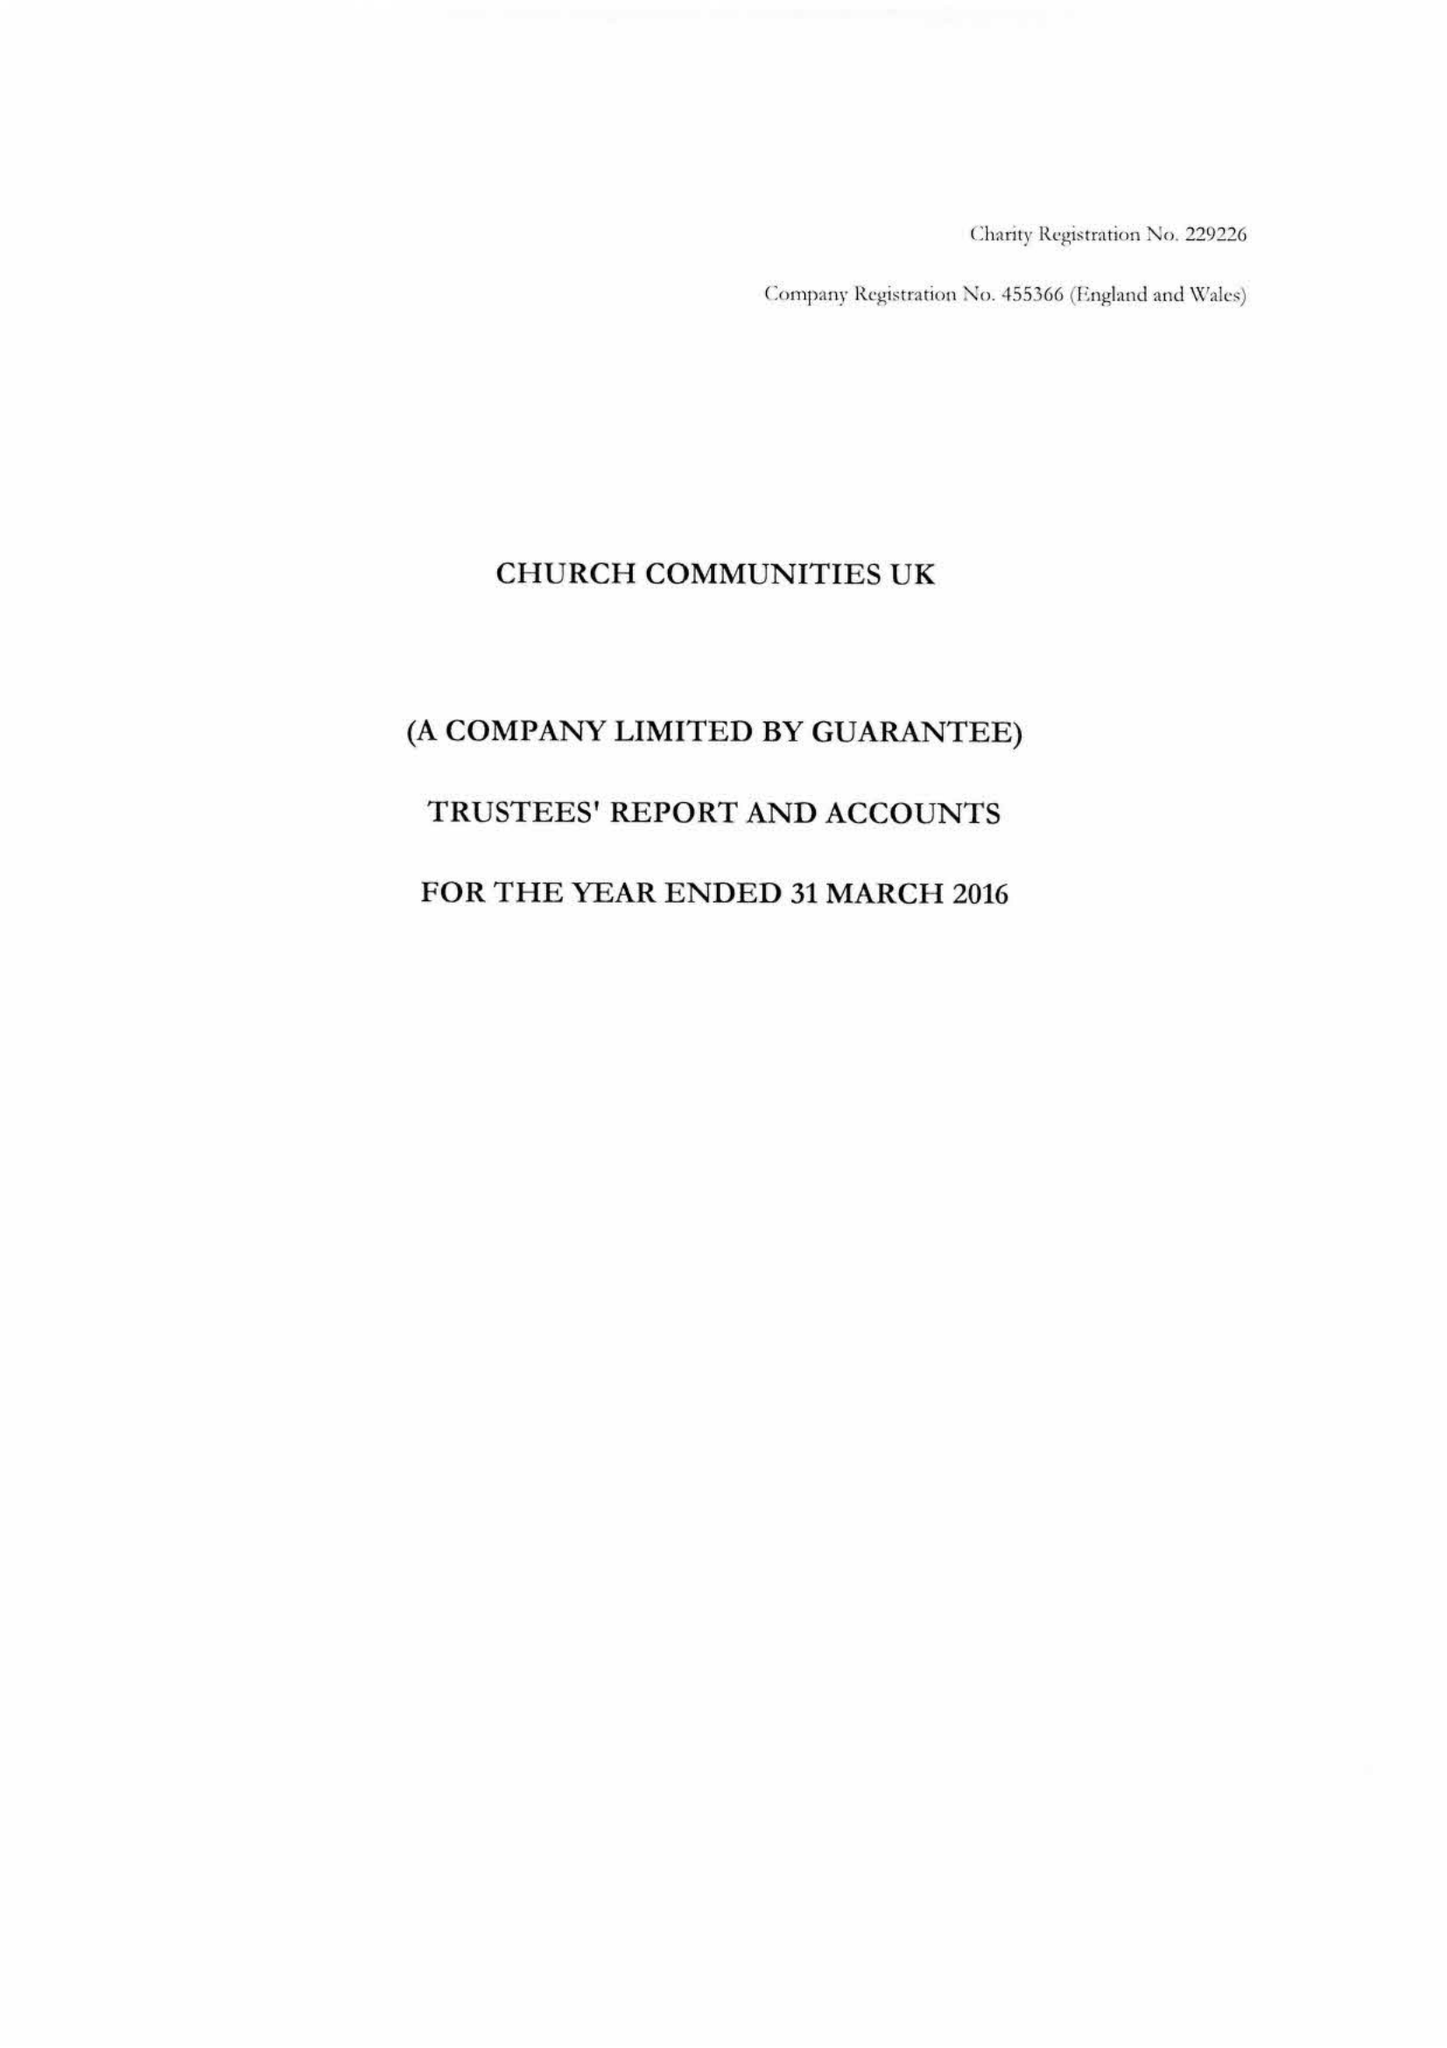What is the value for the address__postcode?
Answer the question using a single word or phrase. TN32 5DR 